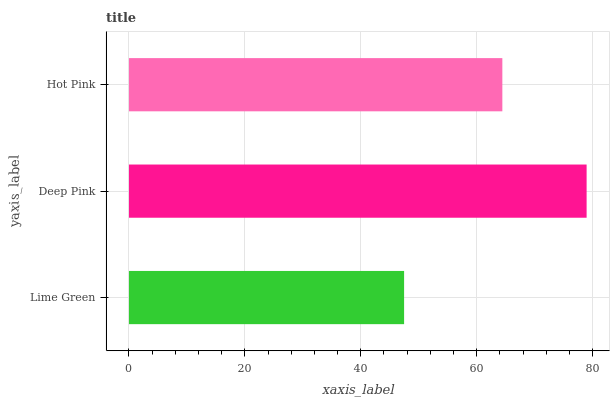Is Lime Green the minimum?
Answer yes or no. Yes. Is Deep Pink the maximum?
Answer yes or no. Yes. Is Hot Pink the minimum?
Answer yes or no. No. Is Hot Pink the maximum?
Answer yes or no. No. Is Deep Pink greater than Hot Pink?
Answer yes or no. Yes. Is Hot Pink less than Deep Pink?
Answer yes or no. Yes. Is Hot Pink greater than Deep Pink?
Answer yes or no. No. Is Deep Pink less than Hot Pink?
Answer yes or no. No. Is Hot Pink the high median?
Answer yes or no. Yes. Is Hot Pink the low median?
Answer yes or no. Yes. Is Lime Green the high median?
Answer yes or no. No. Is Deep Pink the low median?
Answer yes or no. No. 